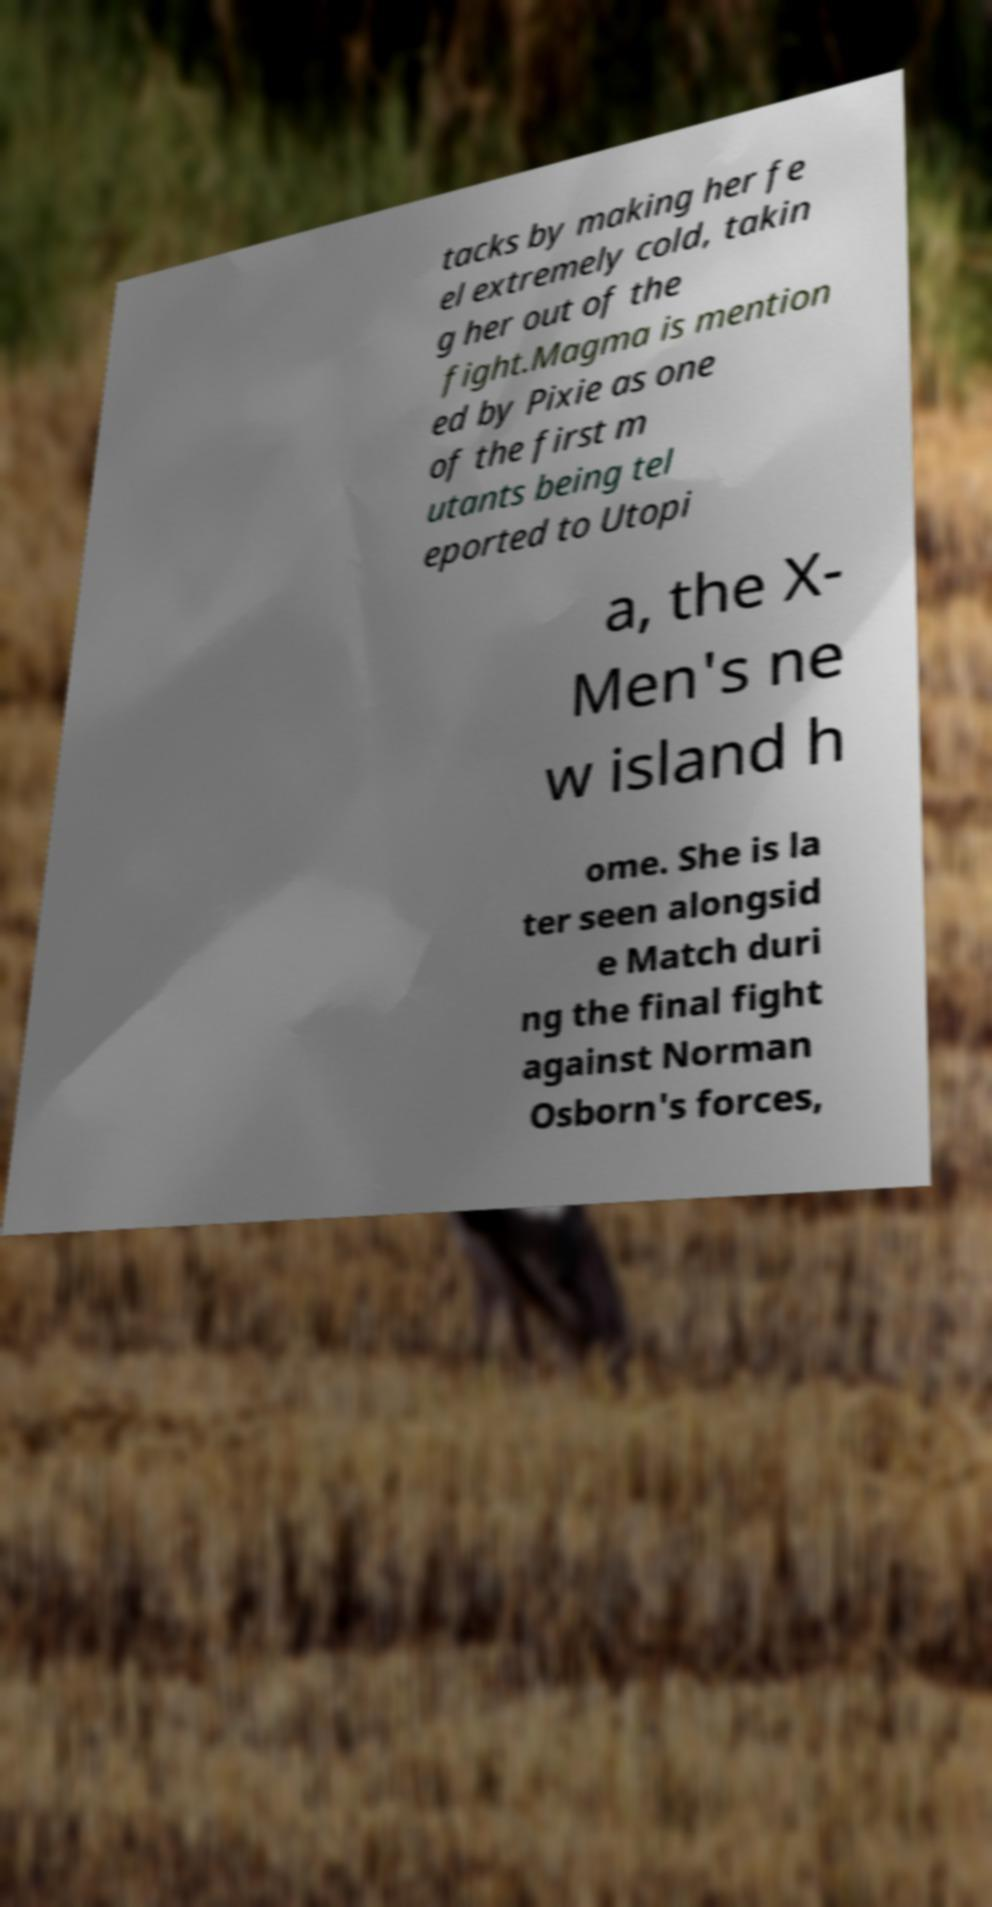Can you accurately transcribe the text from the provided image for me? tacks by making her fe el extremely cold, takin g her out of the fight.Magma is mention ed by Pixie as one of the first m utants being tel eported to Utopi a, the X- Men's ne w island h ome. She is la ter seen alongsid e Match duri ng the final fight against Norman Osborn's forces, 